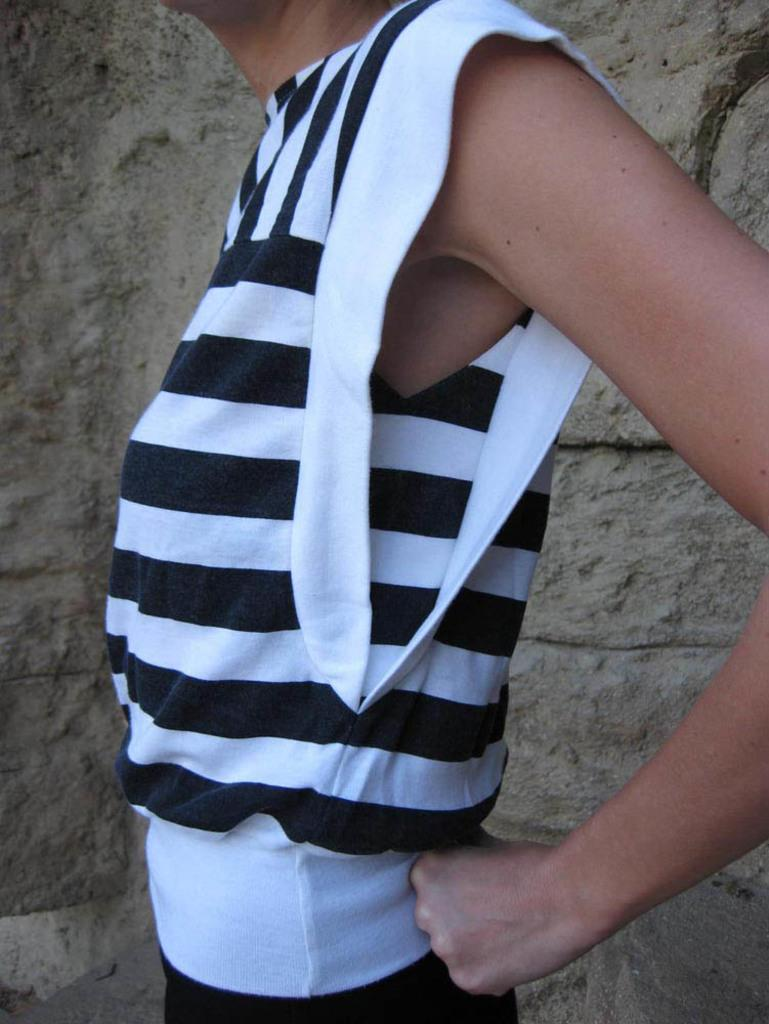Who or what is present in the image? There is a person in the image. What is behind the person in the image? There is a wall behind the person in the image. How many fingers can be seen in the image? There is no information about fingers in the provided facts, so it cannot be determined from the image. 